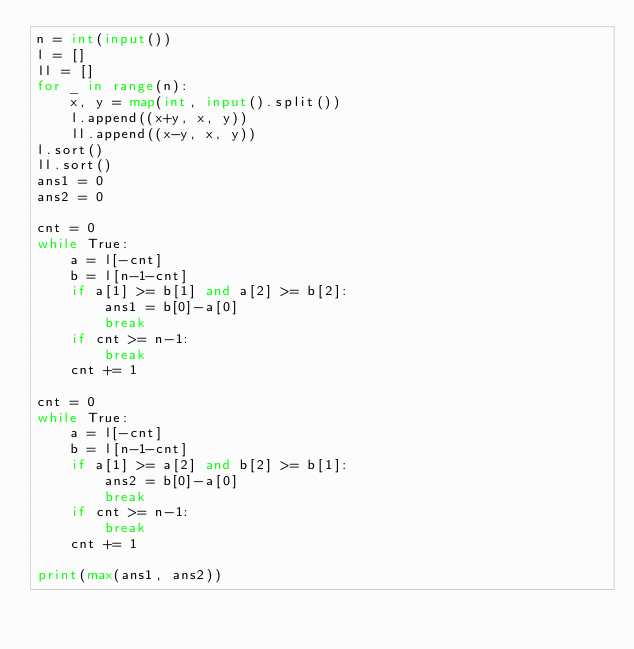<code> <loc_0><loc_0><loc_500><loc_500><_Python_>n = int(input())
l = []
ll = []
for _ in range(n):
    x, y = map(int, input().split())
    l.append((x+y, x, y))
    ll.append((x-y, x, y))
l.sort()
ll.sort()
ans1 = 0
ans2 = 0

cnt = 0
while True:
    a = l[-cnt]
    b = l[n-1-cnt]
    if a[1] >= b[1] and a[2] >= b[2]:
        ans1 = b[0]-a[0]
        break
    if cnt >= n-1:
        break
    cnt += 1

cnt = 0
while True:
    a = l[-cnt]
    b = l[n-1-cnt]
    if a[1] >= a[2] and b[2] >= b[1]:
        ans2 = b[0]-a[0]
        break
    if cnt >= n-1:
        break
    cnt += 1

print(max(ans1, ans2))</code> 